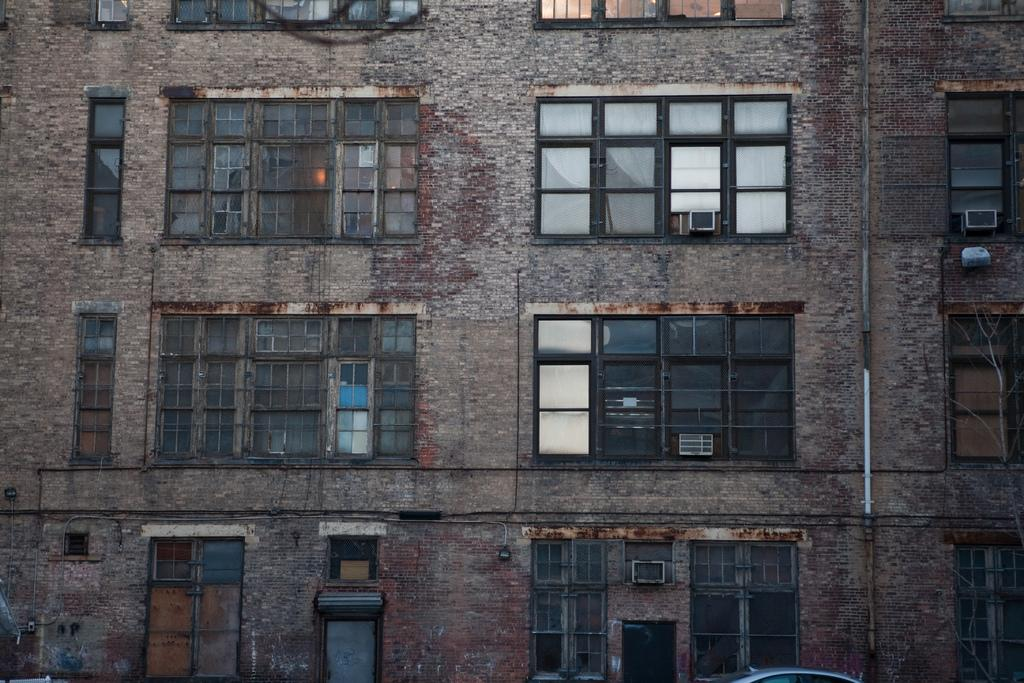What is the main structure visible in the image? There is a building in the image. What is the color of the building? The building is brown in color. What type of material is used for the windows on the building? There are glass windows on the building. How many kitties are sitting on the windowsill of the building in the image? There are no kitties visible in the image. What is the amount of donkeys present in the image? There are no donkeys present in the image. 